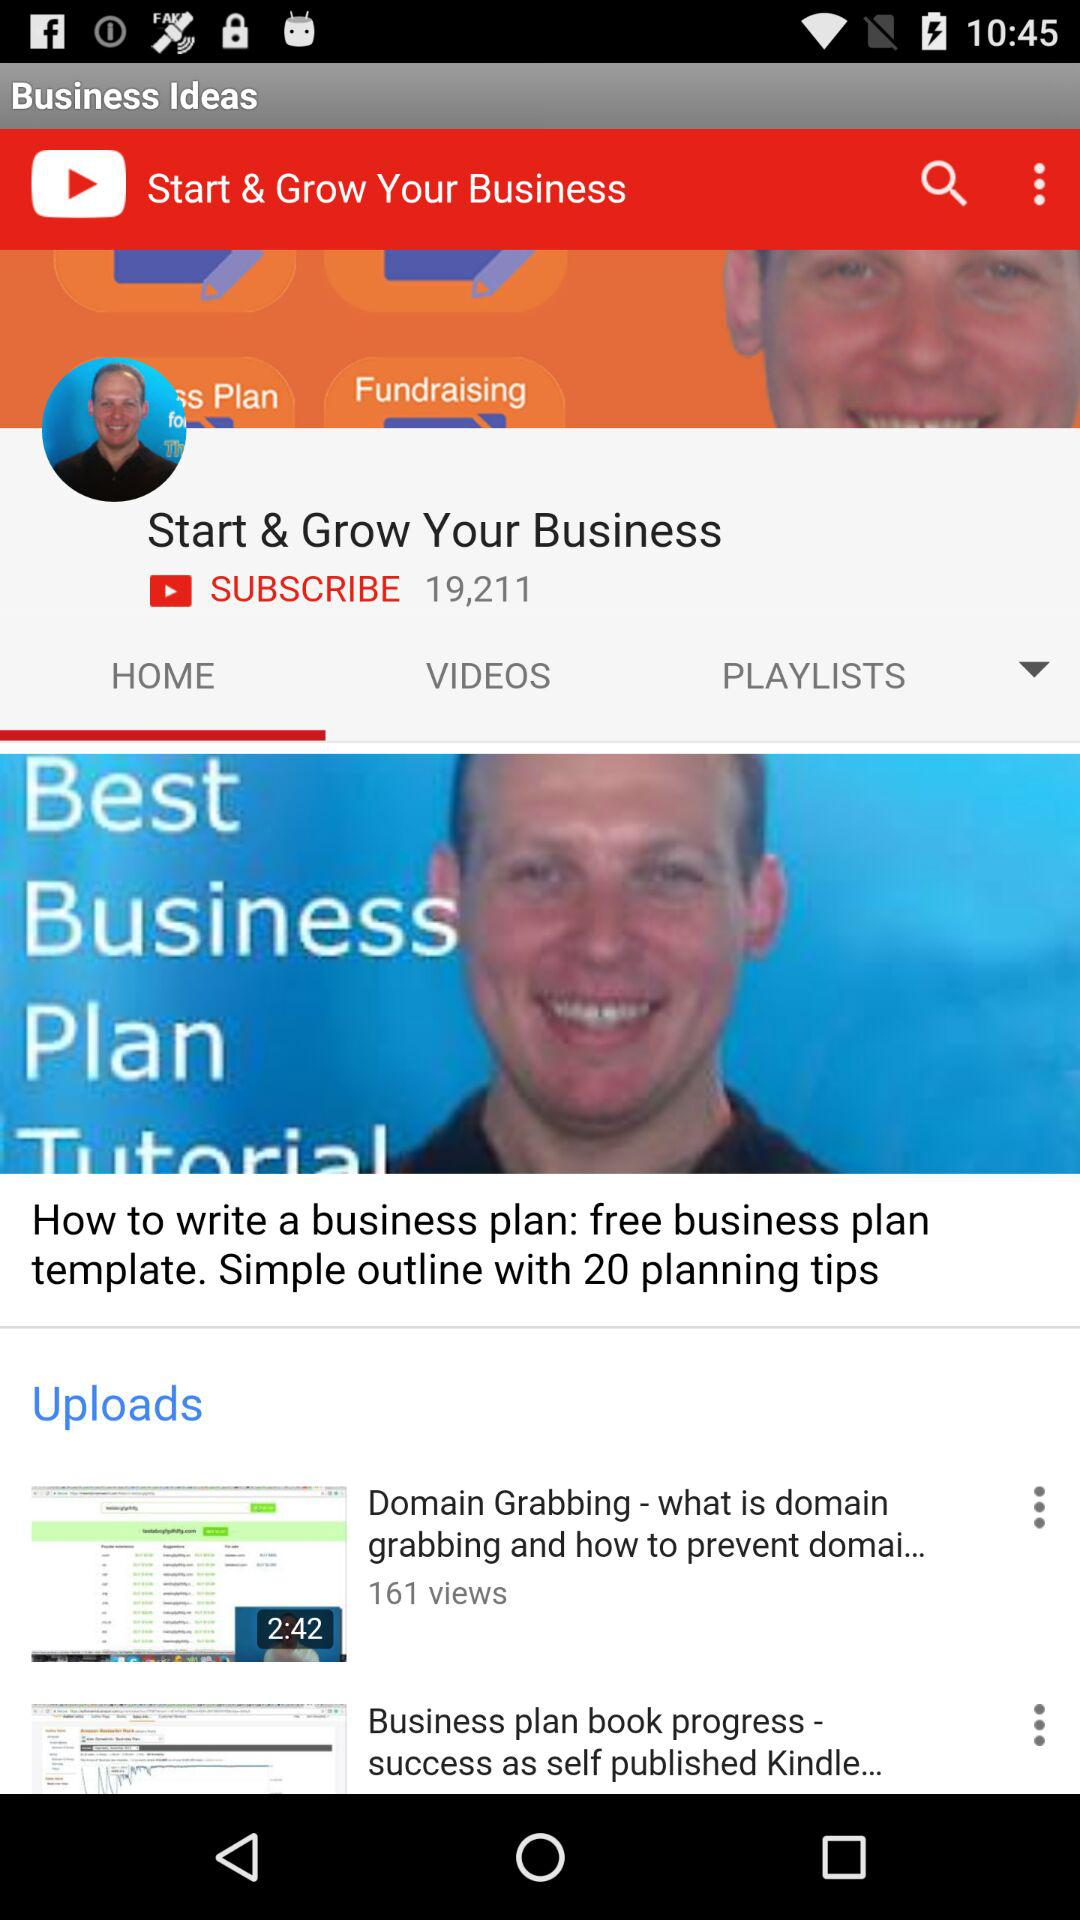How many subscribers are there for this video? There are 19,211 subscribers for this video. 